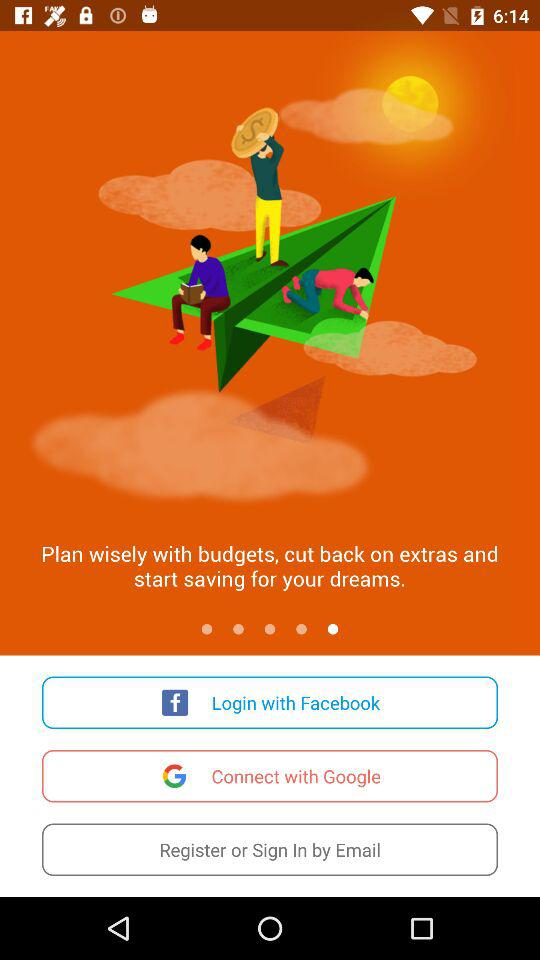What option can be used to sign in? The option "Email" can be used to sign in. 